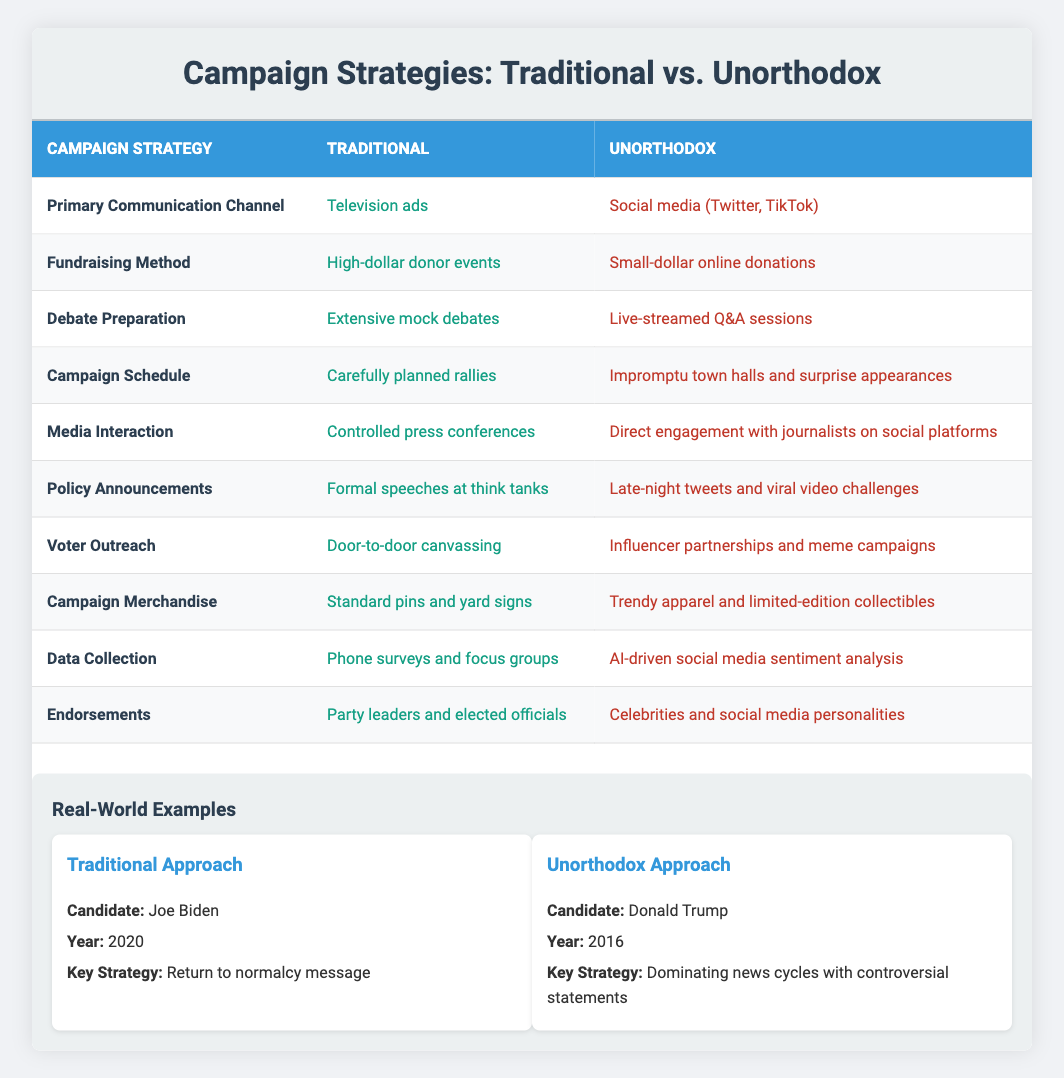What is the primary communication channel for traditional campaign strategies? The table explicitly states that the primary communication channel for traditional campaign strategies is "Television ads." This can be directly retrieved from the "Primary Communication Channel" row in the table.
Answer: Television ads Which fundraising method is preferred in unorthodox campaign strategies? According to the table, the unorthodox strategy for fundraising is "Small-dollar online donations." This is found in the "Fundraising Method" row, indicating the preferred approach in that category.
Answer: Small-dollar online donations Is direct engagement with journalists on social platforms a characteristic of traditional campaign strategies? The table clearly shows that direct engagement with journalists on social platforms is listed under the "Unorthodox" column for "Media Interaction." This indicates that this approach does not characterize traditional strategies, so the answer is no.
Answer: No What are the key differences in voter outreach between traditional and unorthodox strategies? The table highlights "Door-to-door canvassing" as the traditional method and "Influencer partnerships and meme campaigns" as the unorthodox method for voter outreach. The differences lie in the approaches; traditional methods focus on direct physical interaction, while unorthodox methods leverage social media influencers.
Answer: Door-to-door canvassing vs. influencer partnerships and meme campaigns How many different aspects of campaign strategies are compared in this table? The table presents 10 different aspects, each representing a different strategy or method within the campaign process. This can be counted by looking at the number of rows provided under the "Campaign Strategy" header.
Answer: 10 What types of campaign merchandise are associated with unorthodox strategies? The table indicates that unorthodox strategies use "Trendy apparel and limited-edition collectibles" for campaign merchandise. This is clearly noted in the "Campaign Merchandise" row under the unorthodox column.
Answer: Trendy apparel and limited-edition collectibles Which candidate is associated with each campaign strategy approach in the examples section? The examples section attributes "Joe Biden" to traditional strategies in 2020 with the key strategy of "Return to normalcy message," and "Donald Trump" to unorthodox strategies in 2016 with the key strategy of "Dominating news cycles with controversial statements." This verifies the candidates' distinct strategies.
Answer: Joe Biden (traditional), Donald Trump (unorthodox) Are policy announcements made through late-night tweets a conventional practice in political campaigns? The table reveals that "Late-night tweets and viral video challenges" are listed under the unorthodox column for "Policy Announcements." This clearly indicates that such practices do not reflect traditional methods. Thus, the answer is no.
Answer: No What is the difference in debate preparation methods between unorthodox and traditional strategies? The traditional approach is characterized by "Extensive mock debates," while the unorthodox method is indicated as "Live-streamed Q&A sessions." This highlights a significant methodological difference where the traditional strategy relies on rehearsed formats compared to real-time interaction in unorthodox strategies.
Answer: Extensive mock debates vs. live-streamed Q&A sessions Is celebrity endorsement a feature of traditional campaign strategies? The table specifies that "Party leaders and elected officials" are the endorsements for traditional strategies, thus indicating that celebrity endorsements are not part of this approach, confirming the answer as no.
Answer: No 